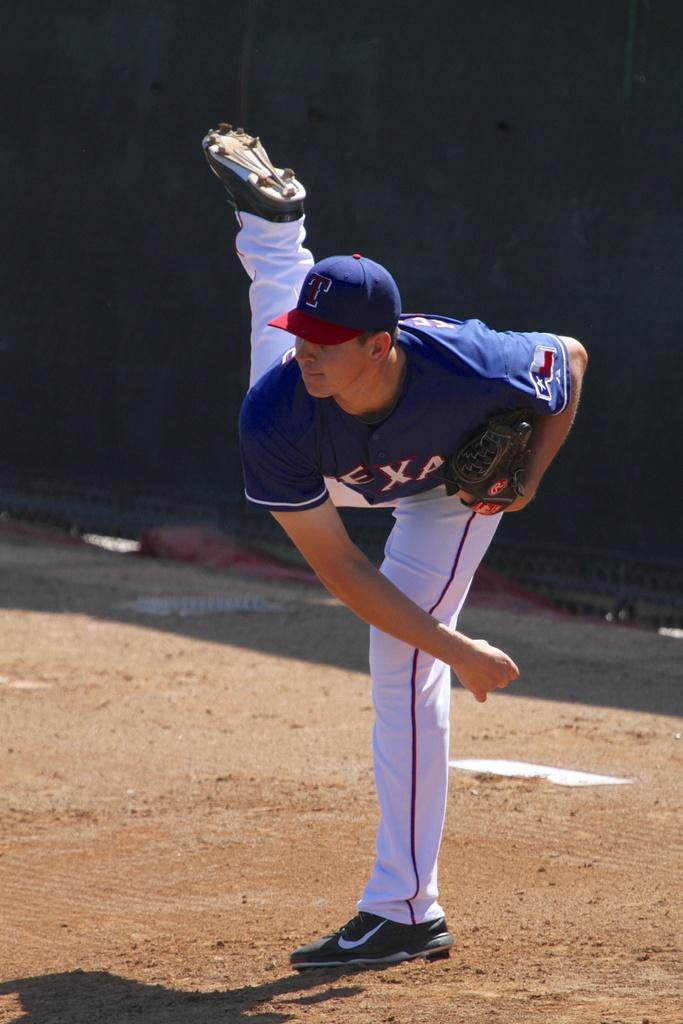What letter is on his hat?
Ensure brevity in your answer.  T. 